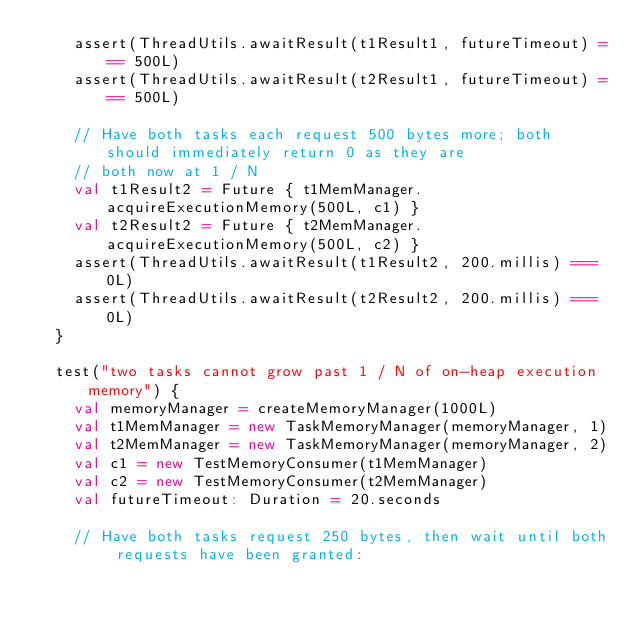<code> <loc_0><loc_0><loc_500><loc_500><_Scala_>    assert(ThreadUtils.awaitResult(t1Result1, futureTimeout) === 500L)
    assert(ThreadUtils.awaitResult(t2Result1, futureTimeout) === 500L)

    // Have both tasks each request 500 bytes more; both should immediately return 0 as they are
    // both now at 1 / N
    val t1Result2 = Future { t1MemManager.acquireExecutionMemory(500L, c1) }
    val t2Result2 = Future { t2MemManager.acquireExecutionMemory(500L, c2) }
    assert(ThreadUtils.awaitResult(t1Result2, 200.millis) === 0L)
    assert(ThreadUtils.awaitResult(t2Result2, 200.millis) === 0L)
  }

  test("two tasks cannot grow past 1 / N of on-heap execution memory") {
    val memoryManager = createMemoryManager(1000L)
    val t1MemManager = new TaskMemoryManager(memoryManager, 1)
    val t2MemManager = new TaskMemoryManager(memoryManager, 2)
    val c1 = new TestMemoryConsumer(t1MemManager)
    val c2 = new TestMemoryConsumer(t2MemManager)
    val futureTimeout: Duration = 20.seconds

    // Have both tasks request 250 bytes, then wait until both requests have been granted:</code> 